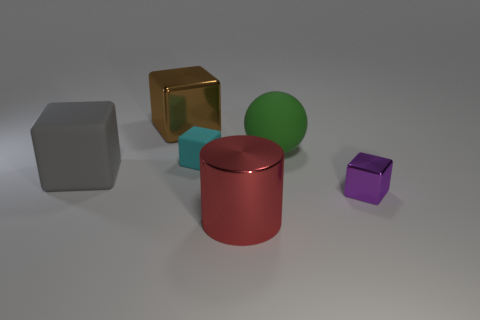Subtract all green cubes. Subtract all brown cylinders. How many cubes are left? 4 Add 2 small red things. How many objects exist? 8 Subtract all balls. How many objects are left? 5 Add 4 large rubber objects. How many large rubber objects are left? 6 Add 4 large matte balls. How many large matte balls exist? 5 Subtract 0 gray cylinders. How many objects are left? 6 Subtract all small balls. Subtract all big shiny objects. How many objects are left? 4 